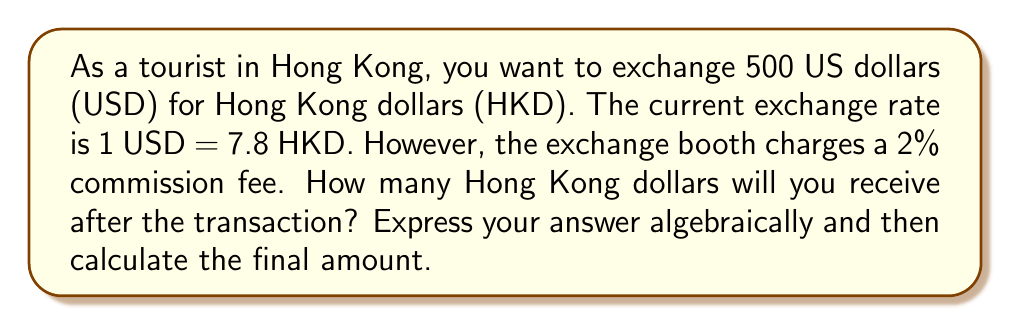Could you help me with this problem? Let's approach this problem step-by-step:

1) First, let's define our variables:
   $x$ = amount of HKD received
   $r$ = exchange rate (1 USD = 7.8 HKD)
   $a$ = amount of USD to exchange (500)
   $c$ = commission rate (2% = 0.02)

2) Without the commission, the exchange would be:
   $x = a \cdot r = 500 \cdot 7.8 = 3900$ HKD

3) However, we need to account for the 2% commission. The commission is applied to the final HKD amount. We can express this algebraically as:
   $x = a \cdot r \cdot (1 - c)$

4) Substituting our values:
   $x = 500 \cdot 7.8 \cdot (1 - 0.02)$

5) Simplifying:
   $x = 3900 \cdot 0.98 = 3822$ HKD

Therefore, after the 2% commission, you will receive 3822 Hong Kong dollars.
Answer: $x = a \cdot r \cdot (1 - c) = 3822$ HKD 